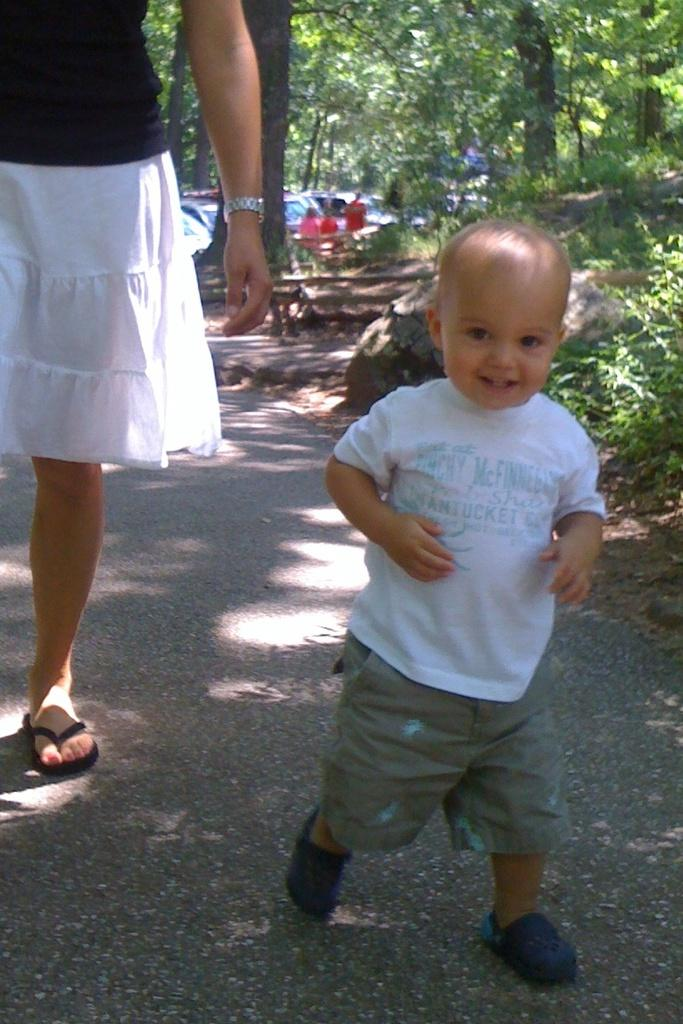What are the people in the image doing? The people in the image are walking on the road. What can be seen near the road in the image? There are trees near the road in the image. What else is visible in the background of the image? There are vehicles visible in the background. How does the cat grip the bit in the image? There is no cat or bit present in the image. 